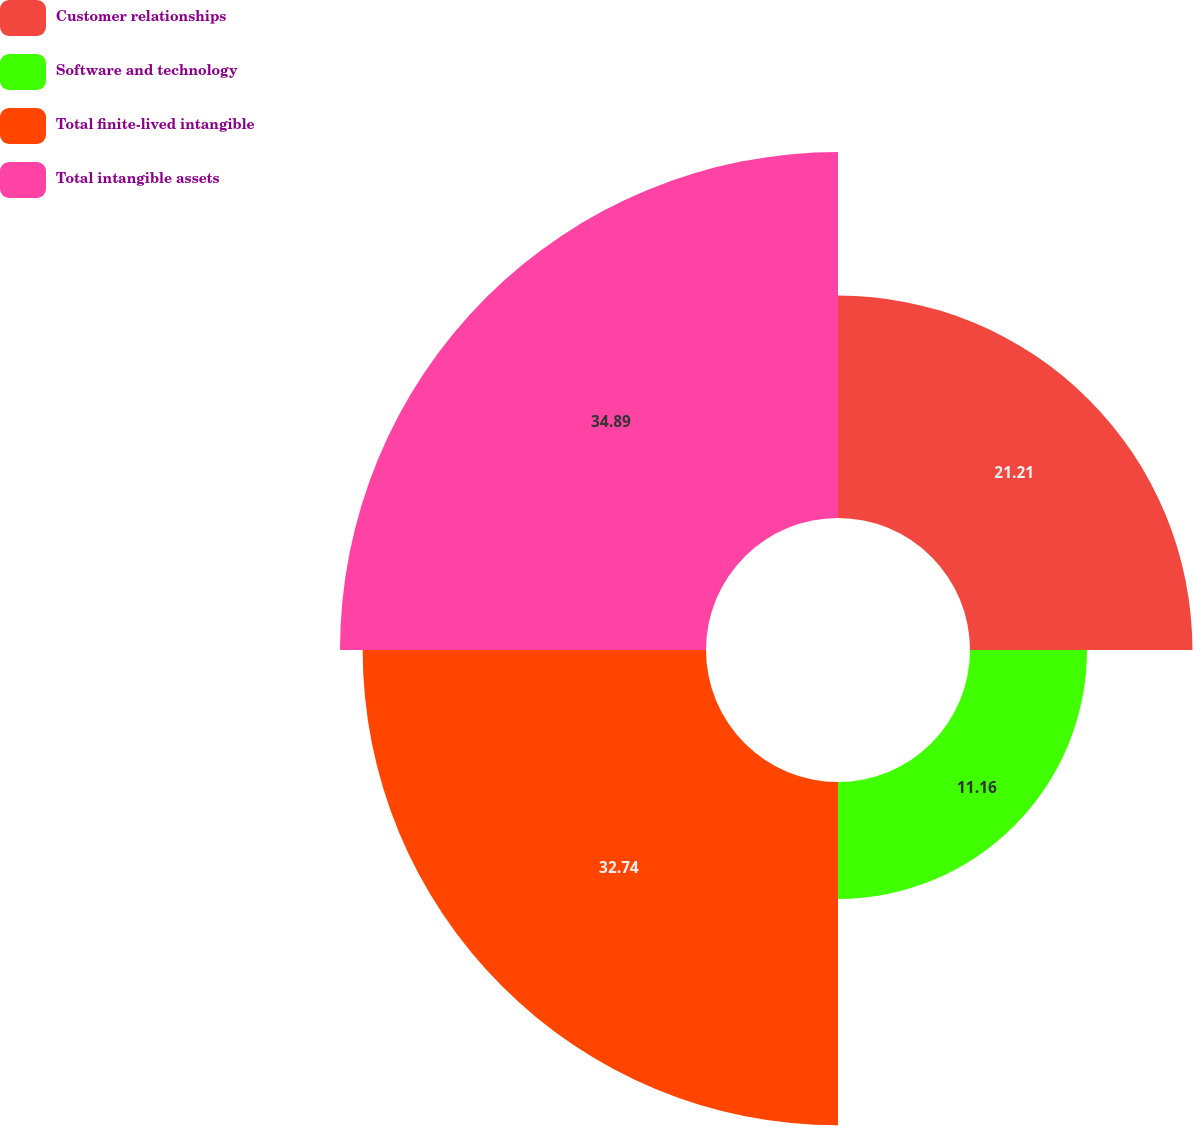<chart> <loc_0><loc_0><loc_500><loc_500><pie_chart><fcel>Customer relationships<fcel>Software and technology<fcel>Total finite-lived intangible<fcel>Total intangible assets<nl><fcel>21.21%<fcel>11.16%<fcel>32.74%<fcel>34.9%<nl></chart> 